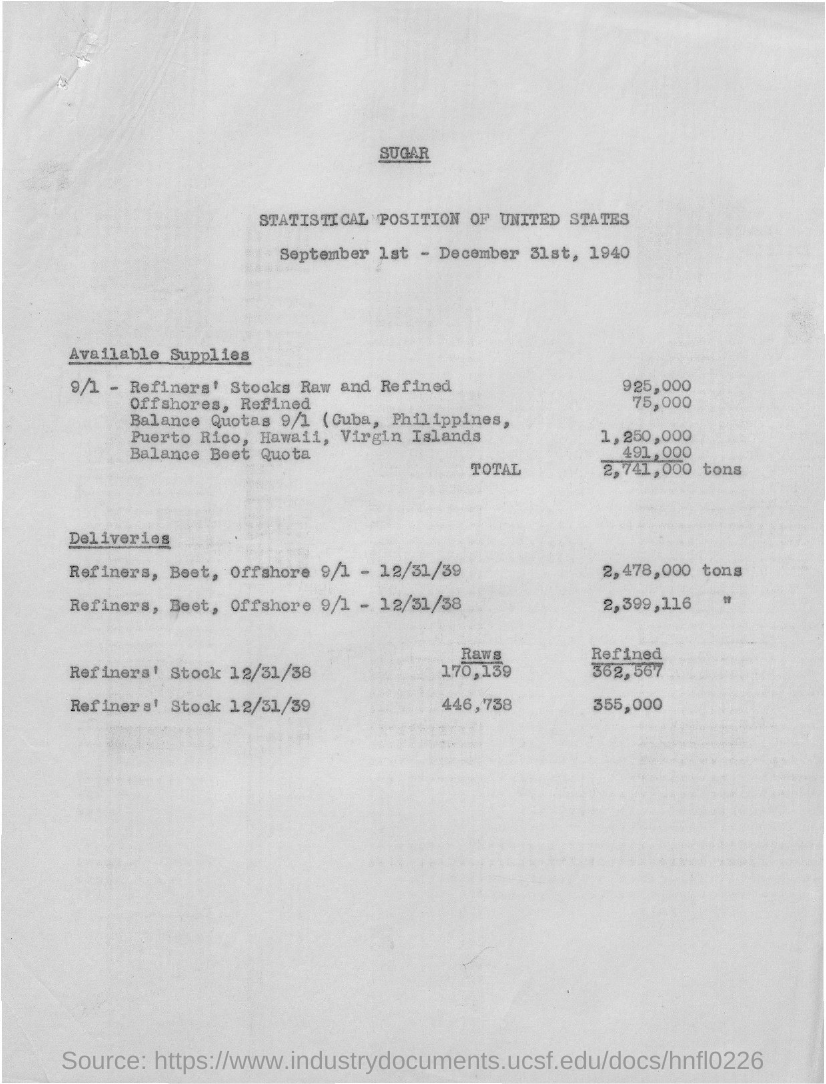What is the Total available supplies?
Give a very brief answer. 2,741,000. What is the Raws refiner's stock 12/31/38?
Ensure brevity in your answer.  170,139. What is the Raws refiner's stock 12/31/39?
Offer a very short reply. 446,738. What is the Refined refiner's stock 12/31/38?
Provide a short and direct response. 362,567. What is the Refined refiner's stock 12/31/39?
Your answer should be compact. 355,000. What are the Refiners, beet, offshore 9/1 - 12/31/39?
Provide a succinct answer. 2,478,000. 